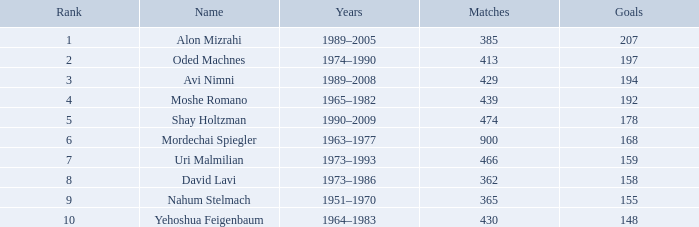What is the status of the player with 158 goals in exceeding 362 matches? 0.0. 